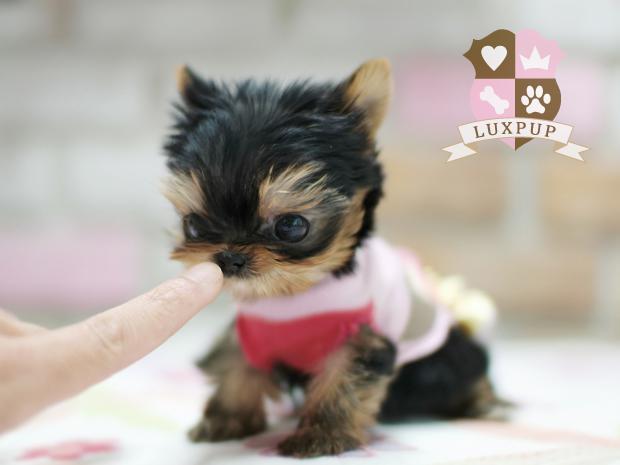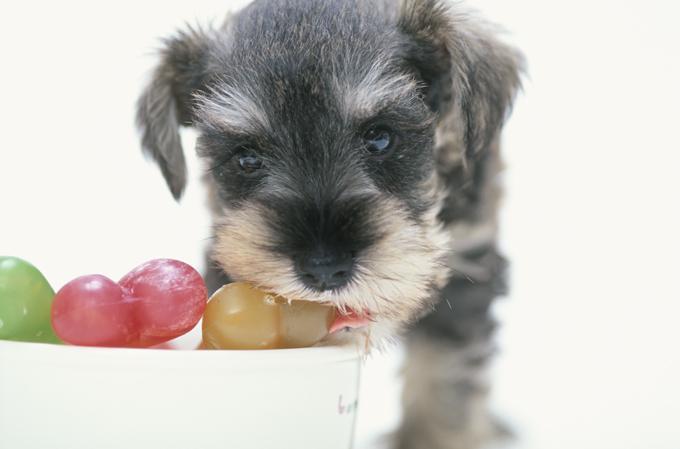The first image is the image on the left, the second image is the image on the right. Examine the images to the left and right. Is the description "The dog in the left image is in a standing pose with body turned to the right." accurate? Answer yes or no. No. 